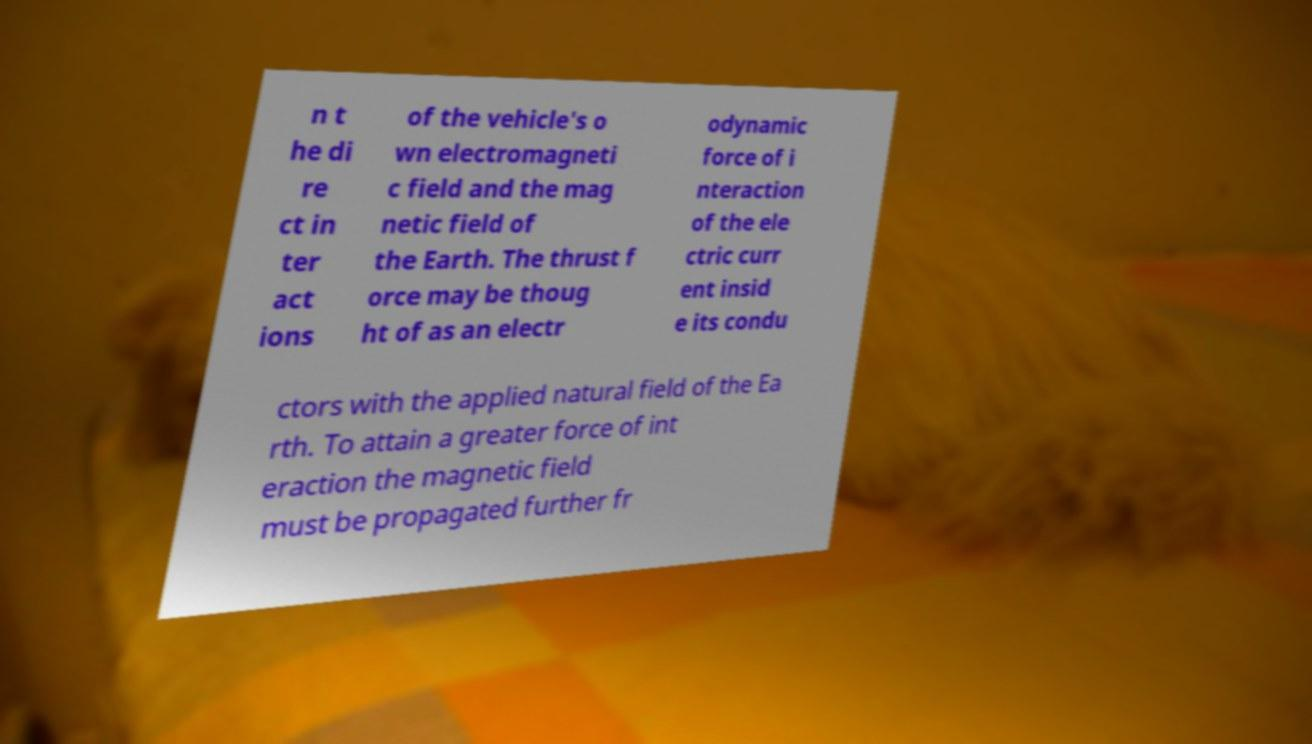Please identify and transcribe the text found in this image. n t he di re ct in ter act ions of the vehicle's o wn electromagneti c field and the mag netic field of the Earth. The thrust f orce may be thoug ht of as an electr odynamic force of i nteraction of the ele ctric curr ent insid e its condu ctors with the applied natural field of the Ea rth. To attain a greater force of int eraction the magnetic field must be propagated further fr 